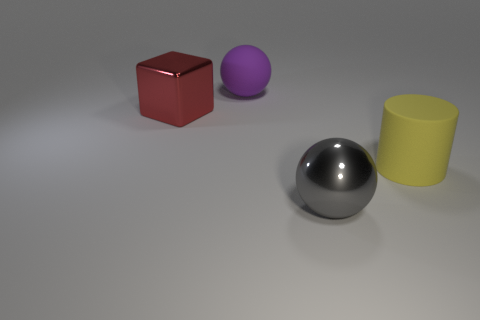Add 1 matte objects. How many objects exist? 5 Subtract all purple spheres. How many spheres are left? 1 Subtract 0 green cylinders. How many objects are left? 4 Subtract all cylinders. How many objects are left? 3 Subtract all brown cubes. Subtract all yellow balls. How many cubes are left? 1 Subtract all purple matte cylinders. Subtract all shiny spheres. How many objects are left? 3 Add 1 big cylinders. How many big cylinders are left? 2 Add 3 yellow matte objects. How many yellow matte objects exist? 4 